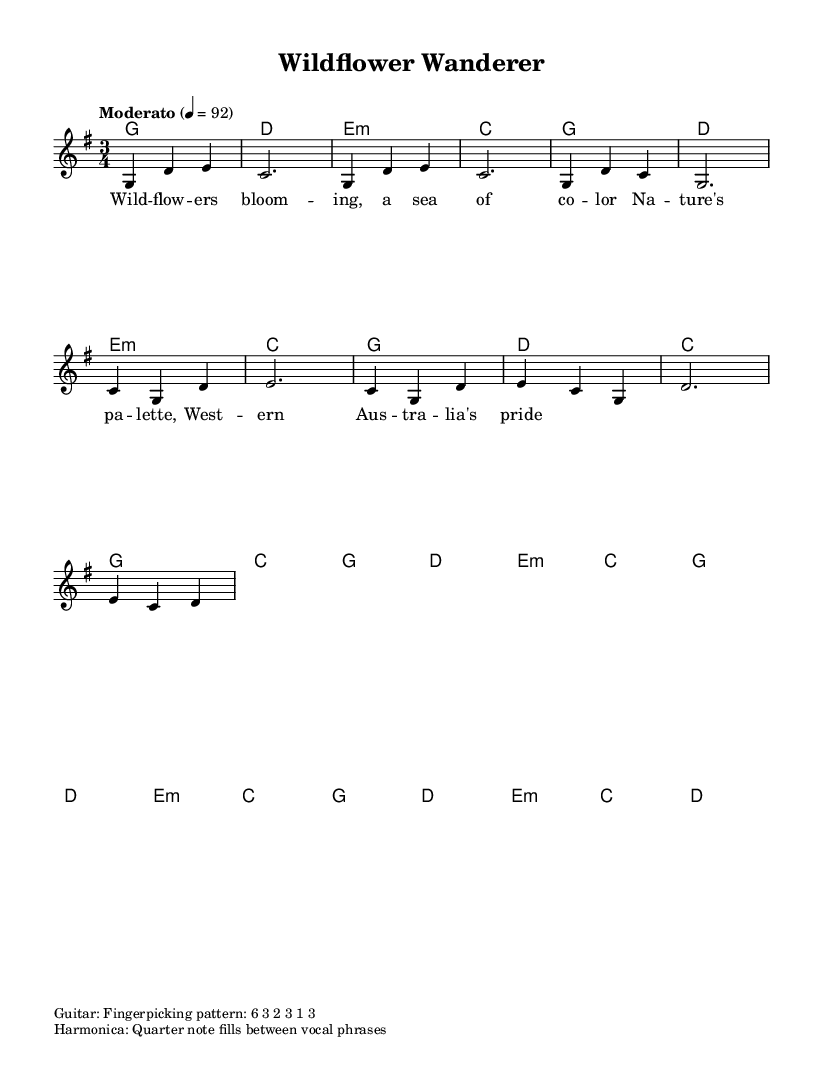What is the key signature of this music? The key signature is G major, which has one sharp (F#). This is indicated at the beginning of the staff where the key signature is shown.
Answer: G major What is the time signature of the piece? The time signature is shown at the beginning of the music, indicating how many beats are in each measure, which in this case is a 3/4 time signature (three beats per measure).
Answer: 3/4 What is the tempo marking for the song? The tempo marking states "Moderato" with a metronome marking of 92 beats per minute. This indicates a moderate speed for the song.
Answer: Moderato, 92 Which chord is played during the chorus? The chorus includes the chords C, G, D, and E minor. The chords are indicated above the staff in the harmonies section.
Answer: C, G, D, E minor What lyrical theme is presented in the first verse? The lyrics reflect the natural beauty of Western Australia, specifically mentioning blooming wildflowers and nature's palette, as noted in the lyric part under the melody.
Answer: Nature's beauty Which instrument has a fingerpicking pattern specified? The guitar is indicated to use a fingerpicking pattern described as "6 3 2 3 1 3," which is shown in the markup section of the sheet music.
Answer: Guitar What kind of fills is indicated for the harmonica? The harmonica is noted to use quarter note fills between vocal phrases, as stated in the markup section of the sheet music.
Answer: Quarter note fills 